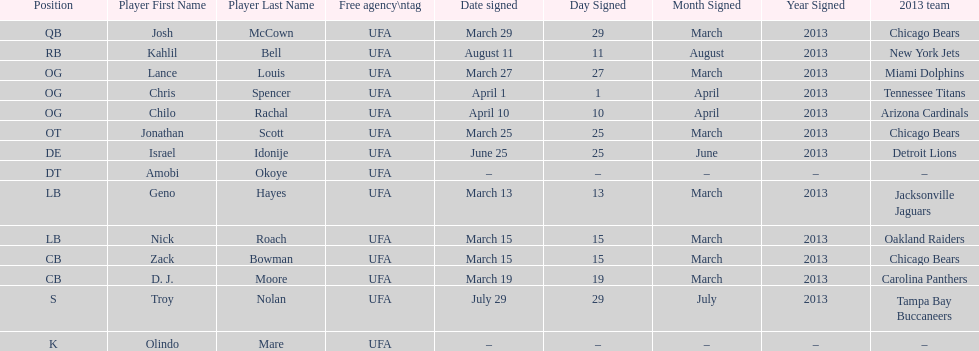Parse the table in full. {'header': ['Position', 'Player First Name', 'Player Last Name', 'Free agency\\ntag', 'Date signed', 'Day Signed', 'Month Signed', 'Year Signed', '2013 team'], 'rows': [['QB', 'Josh', 'McCown', 'UFA', 'March 29', '29', 'March', '2013', 'Chicago Bears'], ['RB', 'Kahlil', 'Bell', 'UFA', 'August 11', '11', 'August', '2013', 'New York Jets'], ['OG', 'Lance', 'Louis', 'UFA', 'March 27', '27', 'March', '2013', 'Miami Dolphins'], ['OG', 'Chris', 'Spencer', 'UFA', 'April 1', '1', 'April', '2013', 'Tennessee Titans'], ['OG', 'Chilo', 'Rachal', 'UFA', 'April 10', '10', 'April', '2013', 'Arizona Cardinals'], ['OT', 'Jonathan', 'Scott', 'UFA', 'March 25', '25', 'March', '2013', 'Chicago Bears'], ['DE', 'Israel', 'Idonije', 'UFA', 'June 25', '25', 'June', '2013', 'Detroit Lions'], ['DT', 'Amobi', 'Okoye', 'UFA', '–', '–', '–', '–', '–'], ['LB', 'Geno', 'Hayes', 'UFA', 'March 13', '13', 'March', '2013', 'Jacksonville Jaguars'], ['LB', 'Nick', 'Roach', 'UFA', 'March 15', '15', 'March', '2013', 'Oakland Raiders'], ['CB', 'Zack', 'Bowman', 'UFA', 'March 15', '15', 'March', '2013', 'Chicago Bears'], ['CB', 'D. J.', 'Moore', 'UFA', 'March 19', '19', 'March', '2013', 'Carolina Panthers'], ['S', 'Troy', 'Nolan', 'UFA', 'July 29', '29', 'July', '2013', 'Tampa Bay Buccaneers'], ['K', 'Olindo', 'Mare', 'UFA', '–', '–', '–', '–', '–']]} How many free agents did this team pick up this season? 14. 